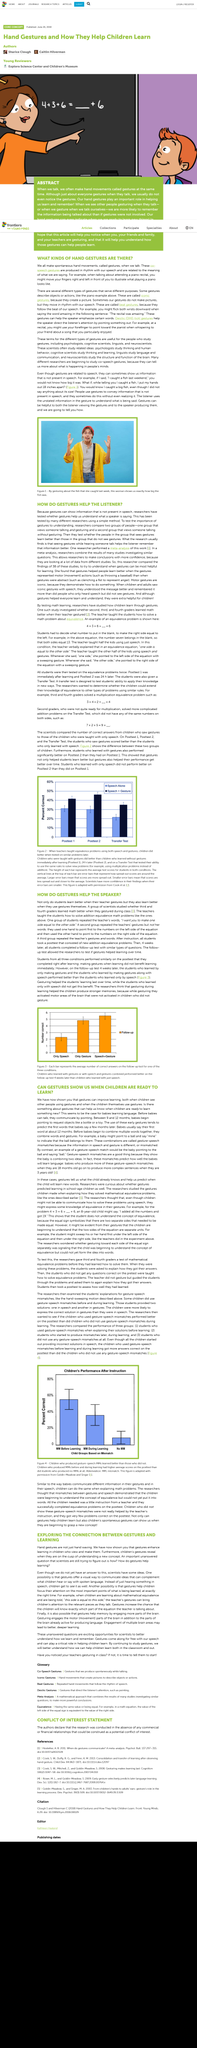Draw attention to some important aspects in this diagram. Iconic gestures are those that create a mental image or representation in the mind of the person interpreting them. The word piano appears three times in the given sentence. 